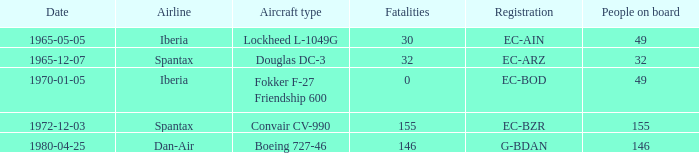How many fatalities shows for the lockheed l-1049g? 30.0. 